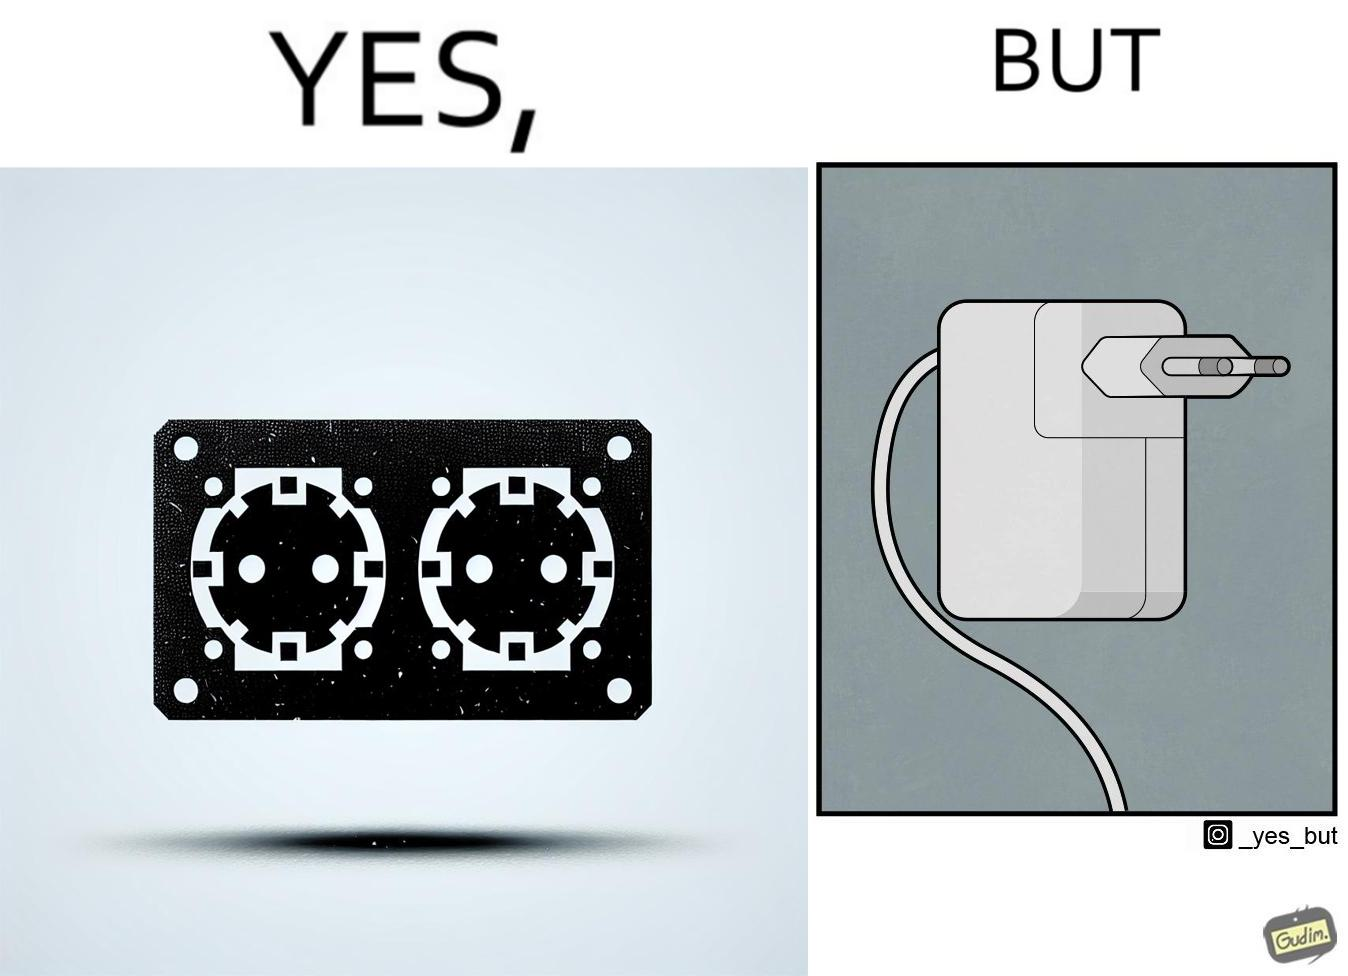What does this image depict? The image is funny, as there are two electrical sockets side-by-side, but the adapter is shaped in such a way, that if two adapters are inserted into the two sockets, they will butt into each other, leading to inconvenience. 